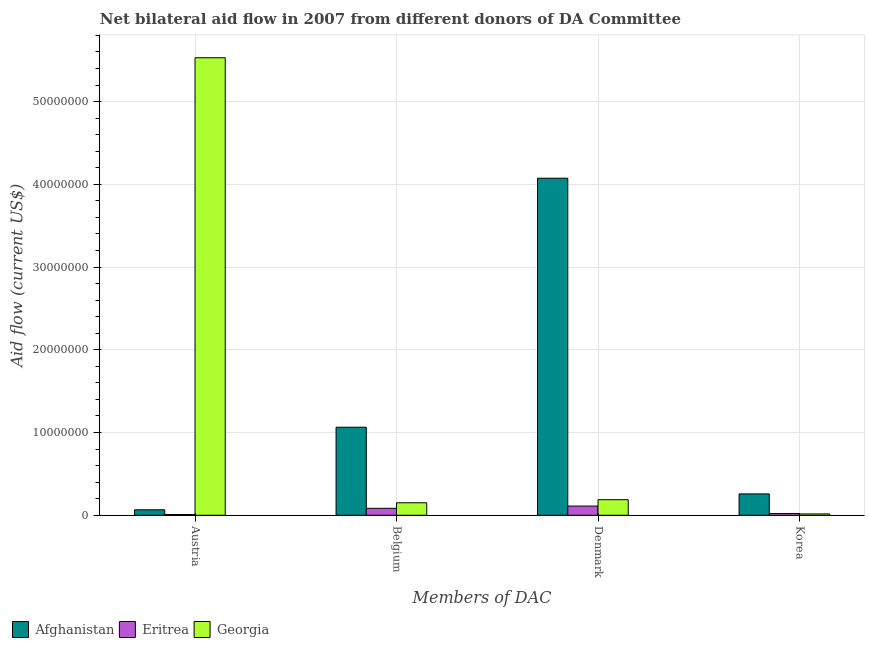How many groups of bars are there?
Provide a short and direct response. 4. Are the number of bars per tick equal to the number of legend labels?
Make the answer very short. Yes. Are the number of bars on each tick of the X-axis equal?
Offer a terse response. Yes. How many bars are there on the 2nd tick from the right?
Ensure brevity in your answer.  3. What is the label of the 4th group of bars from the left?
Provide a short and direct response. Korea. What is the amount of aid given by korea in Afghanistan?
Your answer should be very brief. 2.58e+06. Across all countries, what is the maximum amount of aid given by korea?
Give a very brief answer. 2.58e+06. Across all countries, what is the minimum amount of aid given by denmark?
Make the answer very short. 1.11e+06. In which country was the amount of aid given by austria maximum?
Your answer should be very brief. Georgia. In which country was the amount of aid given by korea minimum?
Your answer should be very brief. Georgia. What is the total amount of aid given by denmark in the graph?
Make the answer very short. 4.37e+07. What is the difference between the amount of aid given by austria in Georgia and that in Eritrea?
Make the answer very short. 5.52e+07. What is the difference between the amount of aid given by belgium in Eritrea and the amount of aid given by denmark in Georgia?
Your answer should be compact. -1.04e+06. What is the average amount of aid given by korea per country?
Keep it short and to the point. 9.83e+05. What is the difference between the amount of aid given by belgium and amount of aid given by denmark in Afghanistan?
Make the answer very short. -3.01e+07. In how many countries, is the amount of aid given by austria greater than 56000000 US$?
Give a very brief answer. 0. What is the ratio of the amount of aid given by austria in Eritrea to that in Georgia?
Ensure brevity in your answer.  0. What is the difference between the highest and the second highest amount of aid given by korea?
Keep it short and to the point. 2.37e+06. What is the difference between the highest and the lowest amount of aid given by denmark?
Your answer should be compact. 3.96e+07. Is it the case that in every country, the sum of the amount of aid given by belgium and amount of aid given by korea is greater than the sum of amount of aid given by denmark and amount of aid given by austria?
Ensure brevity in your answer.  No. What does the 3rd bar from the left in Denmark represents?
Give a very brief answer. Georgia. What does the 3rd bar from the right in Denmark represents?
Your answer should be compact. Afghanistan. How many bars are there?
Ensure brevity in your answer.  12. Are all the bars in the graph horizontal?
Offer a terse response. No. How many countries are there in the graph?
Ensure brevity in your answer.  3. What is the difference between two consecutive major ticks on the Y-axis?
Give a very brief answer. 1.00e+07. Are the values on the major ticks of Y-axis written in scientific E-notation?
Keep it short and to the point. No. How many legend labels are there?
Offer a very short reply. 3. What is the title of the graph?
Offer a very short reply. Net bilateral aid flow in 2007 from different donors of DA Committee. What is the label or title of the X-axis?
Make the answer very short. Members of DAC. What is the label or title of the Y-axis?
Provide a short and direct response. Aid flow (current US$). What is the Aid flow (current US$) in Afghanistan in Austria?
Make the answer very short. 6.60e+05. What is the Aid flow (current US$) of Eritrea in Austria?
Provide a succinct answer. 9.00e+04. What is the Aid flow (current US$) in Georgia in Austria?
Offer a very short reply. 5.53e+07. What is the Aid flow (current US$) of Afghanistan in Belgium?
Give a very brief answer. 1.06e+07. What is the Aid flow (current US$) of Eritrea in Belgium?
Your answer should be very brief. 8.40e+05. What is the Aid flow (current US$) in Georgia in Belgium?
Offer a terse response. 1.51e+06. What is the Aid flow (current US$) of Afghanistan in Denmark?
Offer a very short reply. 4.07e+07. What is the Aid flow (current US$) in Eritrea in Denmark?
Provide a short and direct response. 1.11e+06. What is the Aid flow (current US$) in Georgia in Denmark?
Provide a succinct answer. 1.88e+06. What is the Aid flow (current US$) of Afghanistan in Korea?
Offer a very short reply. 2.58e+06. What is the Aid flow (current US$) in Eritrea in Korea?
Your answer should be compact. 2.10e+05. Across all Members of DAC, what is the maximum Aid flow (current US$) in Afghanistan?
Offer a terse response. 4.07e+07. Across all Members of DAC, what is the maximum Aid flow (current US$) in Eritrea?
Give a very brief answer. 1.11e+06. Across all Members of DAC, what is the maximum Aid flow (current US$) of Georgia?
Offer a terse response. 5.53e+07. Across all Members of DAC, what is the minimum Aid flow (current US$) of Afghanistan?
Offer a very short reply. 6.60e+05. What is the total Aid flow (current US$) of Afghanistan in the graph?
Offer a terse response. 5.46e+07. What is the total Aid flow (current US$) in Eritrea in the graph?
Your response must be concise. 2.25e+06. What is the total Aid flow (current US$) of Georgia in the graph?
Your answer should be compact. 5.88e+07. What is the difference between the Aid flow (current US$) of Afghanistan in Austria and that in Belgium?
Provide a succinct answer. -9.98e+06. What is the difference between the Aid flow (current US$) in Eritrea in Austria and that in Belgium?
Give a very brief answer. -7.50e+05. What is the difference between the Aid flow (current US$) in Georgia in Austria and that in Belgium?
Ensure brevity in your answer.  5.38e+07. What is the difference between the Aid flow (current US$) in Afghanistan in Austria and that in Denmark?
Ensure brevity in your answer.  -4.01e+07. What is the difference between the Aid flow (current US$) of Eritrea in Austria and that in Denmark?
Offer a very short reply. -1.02e+06. What is the difference between the Aid flow (current US$) in Georgia in Austria and that in Denmark?
Offer a very short reply. 5.34e+07. What is the difference between the Aid flow (current US$) in Afghanistan in Austria and that in Korea?
Make the answer very short. -1.92e+06. What is the difference between the Aid flow (current US$) of Eritrea in Austria and that in Korea?
Provide a short and direct response. -1.20e+05. What is the difference between the Aid flow (current US$) of Georgia in Austria and that in Korea?
Give a very brief answer. 5.51e+07. What is the difference between the Aid flow (current US$) in Afghanistan in Belgium and that in Denmark?
Provide a succinct answer. -3.01e+07. What is the difference between the Aid flow (current US$) in Eritrea in Belgium and that in Denmark?
Provide a short and direct response. -2.70e+05. What is the difference between the Aid flow (current US$) in Georgia in Belgium and that in Denmark?
Ensure brevity in your answer.  -3.70e+05. What is the difference between the Aid flow (current US$) in Afghanistan in Belgium and that in Korea?
Ensure brevity in your answer.  8.06e+06. What is the difference between the Aid flow (current US$) of Eritrea in Belgium and that in Korea?
Your answer should be compact. 6.30e+05. What is the difference between the Aid flow (current US$) in Georgia in Belgium and that in Korea?
Ensure brevity in your answer.  1.35e+06. What is the difference between the Aid flow (current US$) of Afghanistan in Denmark and that in Korea?
Give a very brief answer. 3.82e+07. What is the difference between the Aid flow (current US$) of Georgia in Denmark and that in Korea?
Your answer should be very brief. 1.72e+06. What is the difference between the Aid flow (current US$) of Afghanistan in Austria and the Aid flow (current US$) of Georgia in Belgium?
Give a very brief answer. -8.50e+05. What is the difference between the Aid flow (current US$) of Eritrea in Austria and the Aid flow (current US$) of Georgia in Belgium?
Offer a very short reply. -1.42e+06. What is the difference between the Aid flow (current US$) of Afghanistan in Austria and the Aid flow (current US$) of Eritrea in Denmark?
Provide a succinct answer. -4.50e+05. What is the difference between the Aid flow (current US$) in Afghanistan in Austria and the Aid flow (current US$) in Georgia in Denmark?
Ensure brevity in your answer.  -1.22e+06. What is the difference between the Aid flow (current US$) in Eritrea in Austria and the Aid flow (current US$) in Georgia in Denmark?
Make the answer very short. -1.79e+06. What is the difference between the Aid flow (current US$) of Afghanistan in Austria and the Aid flow (current US$) of Georgia in Korea?
Ensure brevity in your answer.  5.00e+05. What is the difference between the Aid flow (current US$) of Afghanistan in Belgium and the Aid flow (current US$) of Eritrea in Denmark?
Offer a very short reply. 9.53e+06. What is the difference between the Aid flow (current US$) of Afghanistan in Belgium and the Aid flow (current US$) of Georgia in Denmark?
Give a very brief answer. 8.76e+06. What is the difference between the Aid flow (current US$) in Eritrea in Belgium and the Aid flow (current US$) in Georgia in Denmark?
Your response must be concise. -1.04e+06. What is the difference between the Aid flow (current US$) in Afghanistan in Belgium and the Aid flow (current US$) in Eritrea in Korea?
Provide a succinct answer. 1.04e+07. What is the difference between the Aid flow (current US$) of Afghanistan in Belgium and the Aid flow (current US$) of Georgia in Korea?
Ensure brevity in your answer.  1.05e+07. What is the difference between the Aid flow (current US$) in Eritrea in Belgium and the Aid flow (current US$) in Georgia in Korea?
Offer a terse response. 6.80e+05. What is the difference between the Aid flow (current US$) of Afghanistan in Denmark and the Aid flow (current US$) of Eritrea in Korea?
Your response must be concise. 4.05e+07. What is the difference between the Aid flow (current US$) of Afghanistan in Denmark and the Aid flow (current US$) of Georgia in Korea?
Your answer should be compact. 4.06e+07. What is the difference between the Aid flow (current US$) in Eritrea in Denmark and the Aid flow (current US$) in Georgia in Korea?
Provide a short and direct response. 9.50e+05. What is the average Aid flow (current US$) in Afghanistan per Members of DAC?
Provide a succinct answer. 1.37e+07. What is the average Aid flow (current US$) of Eritrea per Members of DAC?
Provide a succinct answer. 5.62e+05. What is the average Aid flow (current US$) in Georgia per Members of DAC?
Make the answer very short. 1.47e+07. What is the difference between the Aid flow (current US$) of Afghanistan and Aid flow (current US$) of Eritrea in Austria?
Your answer should be very brief. 5.70e+05. What is the difference between the Aid flow (current US$) of Afghanistan and Aid flow (current US$) of Georgia in Austria?
Provide a succinct answer. -5.46e+07. What is the difference between the Aid flow (current US$) of Eritrea and Aid flow (current US$) of Georgia in Austria?
Give a very brief answer. -5.52e+07. What is the difference between the Aid flow (current US$) of Afghanistan and Aid flow (current US$) of Eritrea in Belgium?
Keep it short and to the point. 9.80e+06. What is the difference between the Aid flow (current US$) in Afghanistan and Aid flow (current US$) in Georgia in Belgium?
Your response must be concise. 9.13e+06. What is the difference between the Aid flow (current US$) in Eritrea and Aid flow (current US$) in Georgia in Belgium?
Give a very brief answer. -6.70e+05. What is the difference between the Aid flow (current US$) of Afghanistan and Aid flow (current US$) of Eritrea in Denmark?
Give a very brief answer. 3.96e+07. What is the difference between the Aid flow (current US$) in Afghanistan and Aid flow (current US$) in Georgia in Denmark?
Give a very brief answer. 3.89e+07. What is the difference between the Aid flow (current US$) of Eritrea and Aid flow (current US$) of Georgia in Denmark?
Give a very brief answer. -7.70e+05. What is the difference between the Aid flow (current US$) in Afghanistan and Aid flow (current US$) in Eritrea in Korea?
Offer a terse response. 2.37e+06. What is the difference between the Aid flow (current US$) in Afghanistan and Aid flow (current US$) in Georgia in Korea?
Make the answer very short. 2.42e+06. What is the difference between the Aid flow (current US$) in Eritrea and Aid flow (current US$) in Georgia in Korea?
Provide a succinct answer. 5.00e+04. What is the ratio of the Aid flow (current US$) of Afghanistan in Austria to that in Belgium?
Your answer should be very brief. 0.06. What is the ratio of the Aid flow (current US$) of Eritrea in Austria to that in Belgium?
Your answer should be very brief. 0.11. What is the ratio of the Aid flow (current US$) in Georgia in Austria to that in Belgium?
Ensure brevity in your answer.  36.62. What is the ratio of the Aid flow (current US$) of Afghanistan in Austria to that in Denmark?
Give a very brief answer. 0.02. What is the ratio of the Aid flow (current US$) of Eritrea in Austria to that in Denmark?
Keep it short and to the point. 0.08. What is the ratio of the Aid flow (current US$) in Georgia in Austria to that in Denmark?
Keep it short and to the point. 29.41. What is the ratio of the Aid flow (current US$) in Afghanistan in Austria to that in Korea?
Offer a very short reply. 0.26. What is the ratio of the Aid flow (current US$) in Eritrea in Austria to that in Korea?
Your answer should be very brief. 0.43. What is the ratio of the Aid flow (current US$) in Georgia in Austria to that in Korea?
Your response must be concise. 345.62. What is the ratio of the Aid flow (current US$) in Afghanistan in Belgium to that in Denmark?
Give a very brief answer. 0.26. What is the ratio of the Aid flow (current US$) of Eritrea in Belgium to that in Denmark?
Provide a succinct answer. 0.76. What is the ratio of the Aid flow (current US$) of Georgia in Belgium to that in Denmark?
Give a very brief answer. 0.8. What is the ratio of the Aid flow (current US$) in Afghanistan in Belgium to that in Korea?
Provide a short and direct response. 4.12. What is the ratio of the Aid flow (current US$) of Eritrea in Belgium to that in Korea?
Provide a succinct answer. 4. What is the ratio of the Aid flow (current US$) of Georgia in Belgium to that in Korea?
Ensure brevity in your answer.  9.44. What is the ratio of the Aid flow (current US$) of Afghanistan in Denmark to that in Korea?
Offer a very short reply. 15.79. What is the ratio of the Aid flow (current US$) in Eritrea in Denmark to that in Korea?
Your answer should be compact. 5.29. What is the ratio of the Aid flow (current US$) of Georgia in Denmark to that in Korea?
Your response must be concise. 11.75. What is the difference between the highest and the second highest Aid flow (current US$) in Afghanistan?
Offer a terse response. 3.01e+07. What is the difference between the highest and the second highest Aid flow (current US$) in Eritrea?
Provide a succinct answer. 2.70e+05. What is the difference between the highest and the second highest Aid flow (current US$) in Georgia?
Ensure brevity in your answer.  5.34e+07. What is the difference between the highest and the lowest Aid flow (current US$) in Afghanistan?
Offer a terse response. 4.01e+07. What is the difference between the highest and the lowest Aid flow (current US$) in Eritrea?
Offer a very short reply. 1.02e+06. What is the difference between the highest and the lowest Aid flow (current US$) in Georgia?
Offer a terse response. 5.51e+07. 